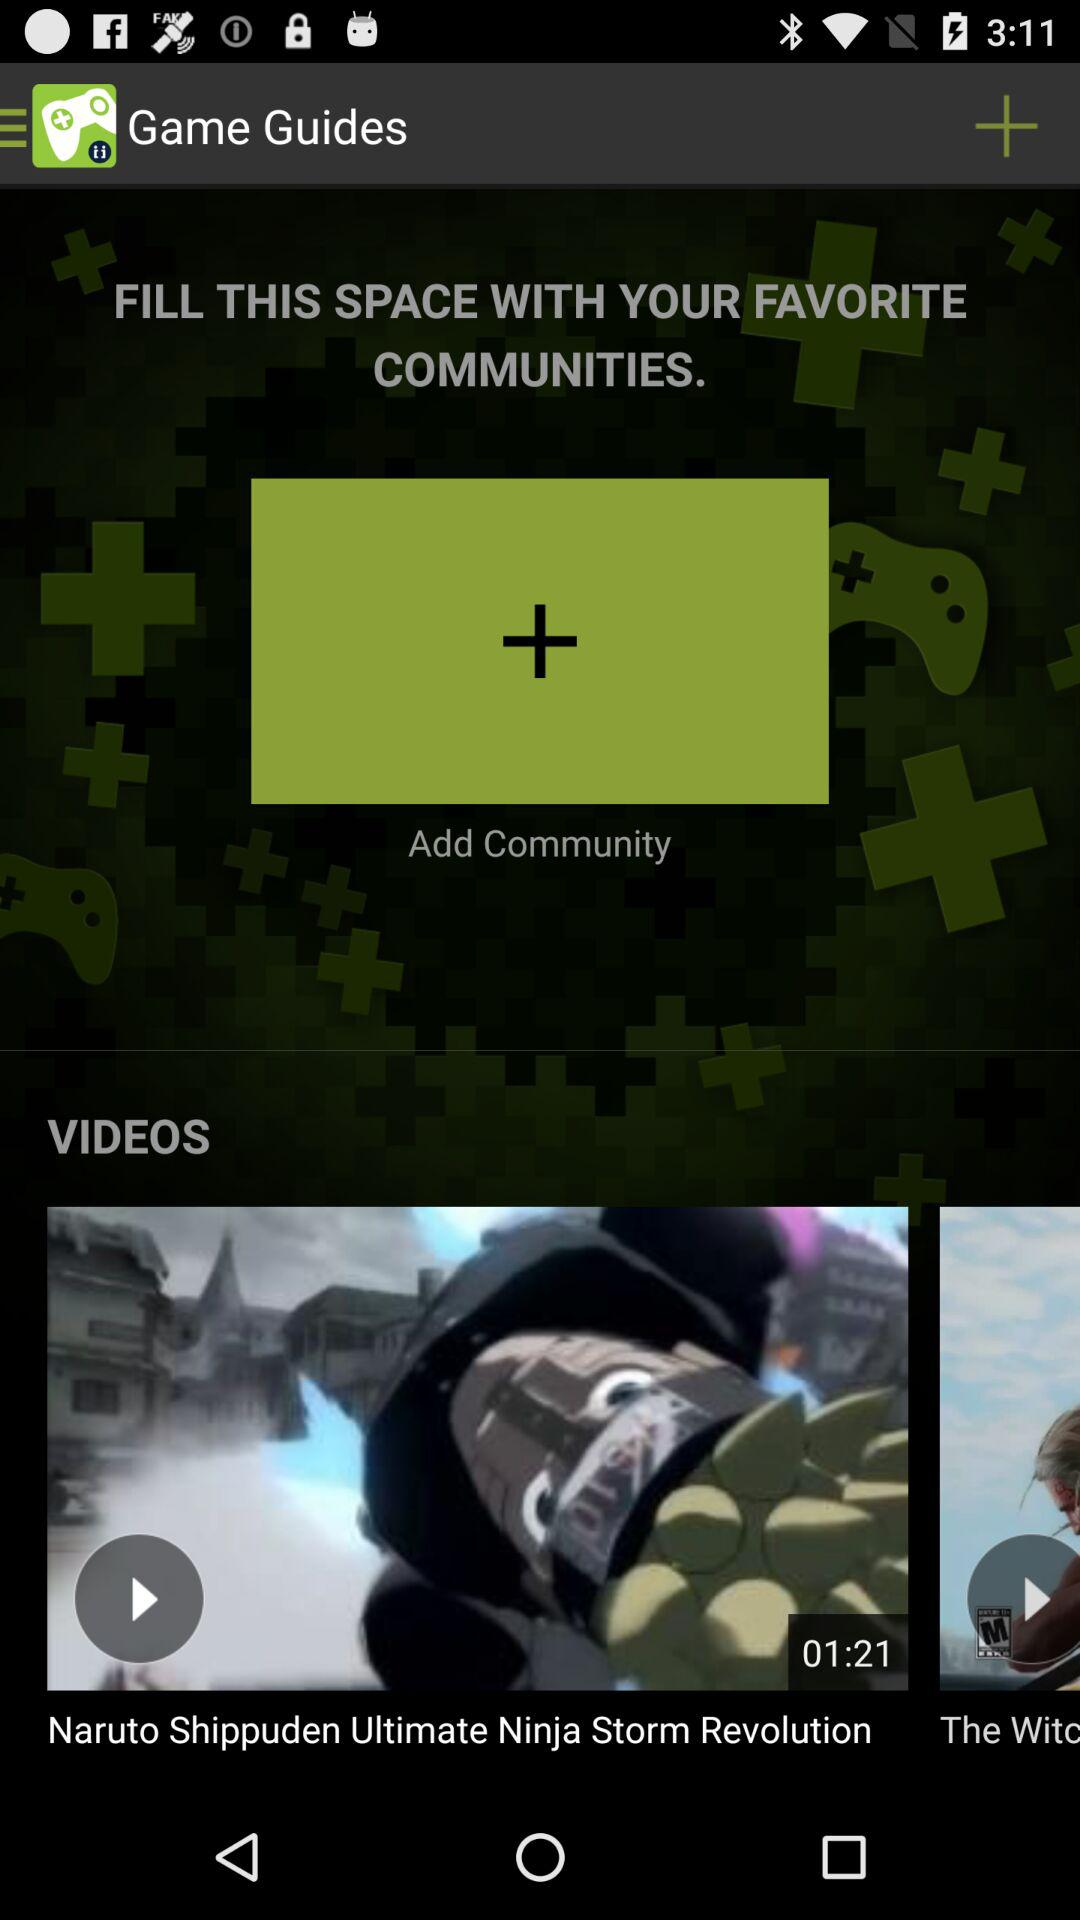What is the duration of the "Naruto Shippuden Ultimate Ninja Storm Revolution" video? The duration of the video is "01:21". 